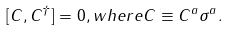Convert formula to latex. <formula><loc_0><loc_0><loc_500><loc_500>[ C , C ^ { \dagger } ] = 0 , w h e r e C \equiv C ^ { a } \sigma ^ { a } .</formula> 